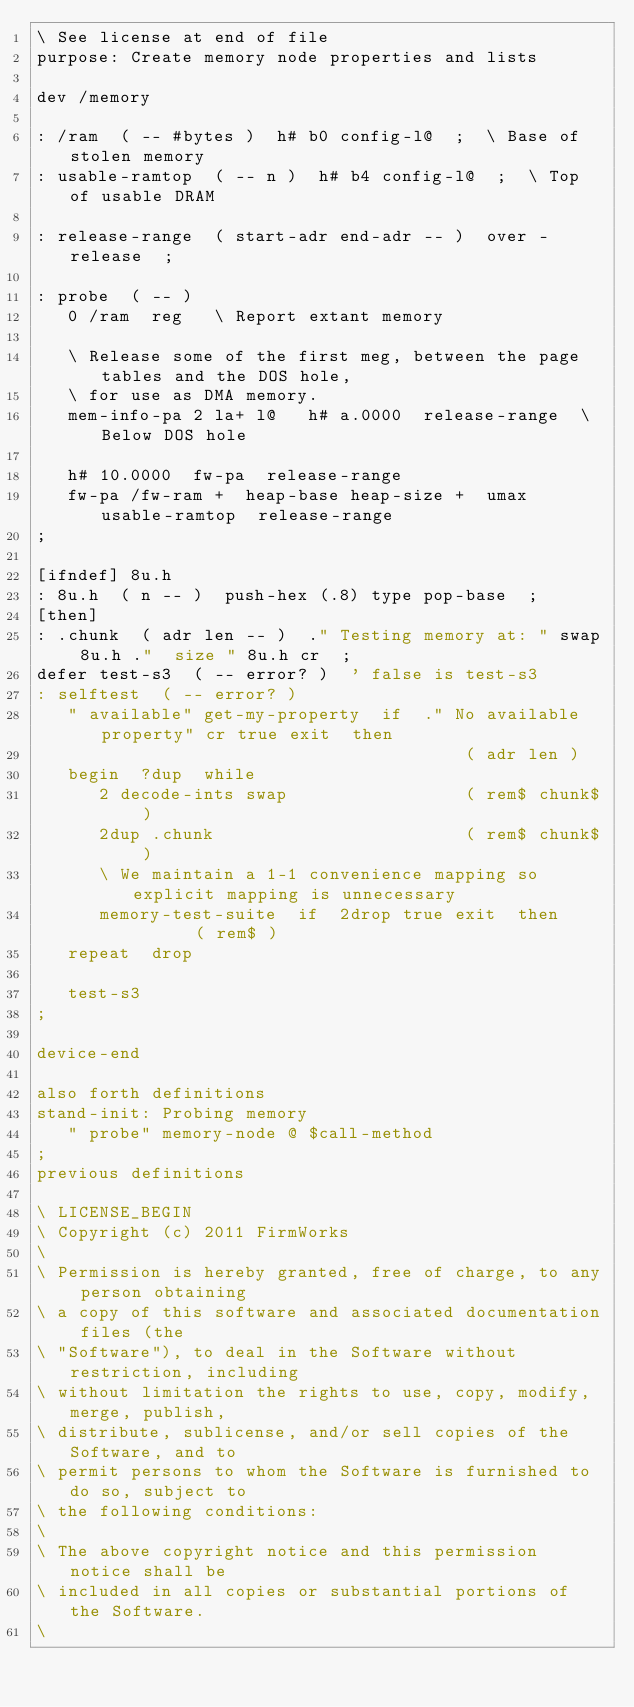Convert code to text. <code><loc_0><loc_0><loc_500><loc_500><_Forth_>\ See license at end of file
purpose: Create memory node properties and lists

dev /memory

: /ram  ( -- #bytes )  h# b0 config-l@  ;  \ Base of stolen memory
: usable-ramtop  ( -- n )  h# b4 config-l@  ;  \ Top of usable DRAM

: release-range  ( start-adr end-adr -- )  over - release  ;

: probe  ( -- )
   0 /ram  reg   \ Report extant memory

   \ Release some of the first meg, between the page tables and the DOS hole,
   \ for use as DMA memory.
   mem-info-pa 2 la+ l@   h# a.0000  release-range  \ Below DOS hole

   h# 10.0000  fw-pa  release-range
   fw-pa /fw-ram +  heap-base heap-size +  umax  usable-ramtop  release-range
;

[ifndef] 8u.h
: 8u.h  ( n -- )  push-hex (.8) type pop-base  ;
[then]
: .chunk  ( adr len -- )  ." Testing memory at: " swap 8u.h ."  size " 8u.h cr  ;
defer test-s3  ( -- error? )  ' false is test-s3
: selftest  ( -- error? )
   " available" get-my-property  if  ." No available property" cr true exit  then
                                         ( adr len )
   begin  ?dup  while
      2 decode-ints swap                 ( rem$ chunk$ )
      2dup .chunk                        ( rem$ chunk$ )
      \ We maintain a 1-1 convenience mapping so explicit mapping is unnecessary
      memory-test-suite  if  2drop true exit  then       ( rem$ )
   repeat  drop

   test-s3
;

device-end

also forth definitions
stand-init: Probing memory
   " probe" memory-node @ $call-method  
;
previous definitions

\ LICENSE_BEGIN
\ Copyright (c) 2011 FirmWorks
\ 
\ Permission is hereby granted, free of charge, to any person obtaining
\ a copy of this software and associated documentation files (the
\ "Software"), to deal in the Software without restriction, including
\ without limitation the rights to use, copy, modify, merge, publish,
\ distribute, sublicense, and/or sell copies of the Software, and to
\ permit persons to whom the Software is furnished to do so, subject to
\ the following conditions:
\ 
\ The above copyright notice and this permission notice shall be
\ included in all copies or substantial portions of the Software.
\ </code> 